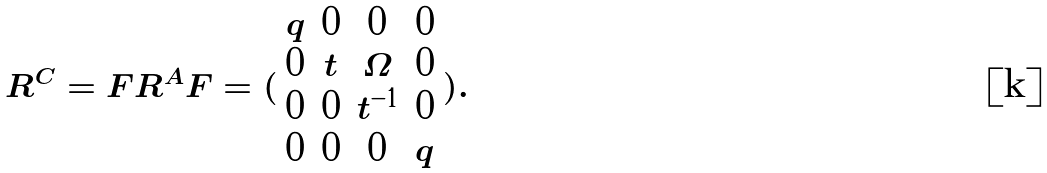Convert formula to latex. <formula><loc_0><loc_0><loc_500><loc_500>R ^ { C } = F R ^ { A } F = ( \begin{array} { c c c c } q & 0 & 0 & 0 \\ 0 & t & \Omega & 0 \\ 0 & 0 & t ^ { - 1 } & 0 \\ 0 & 0 & 0 & q \end{array} ) .</formula> 